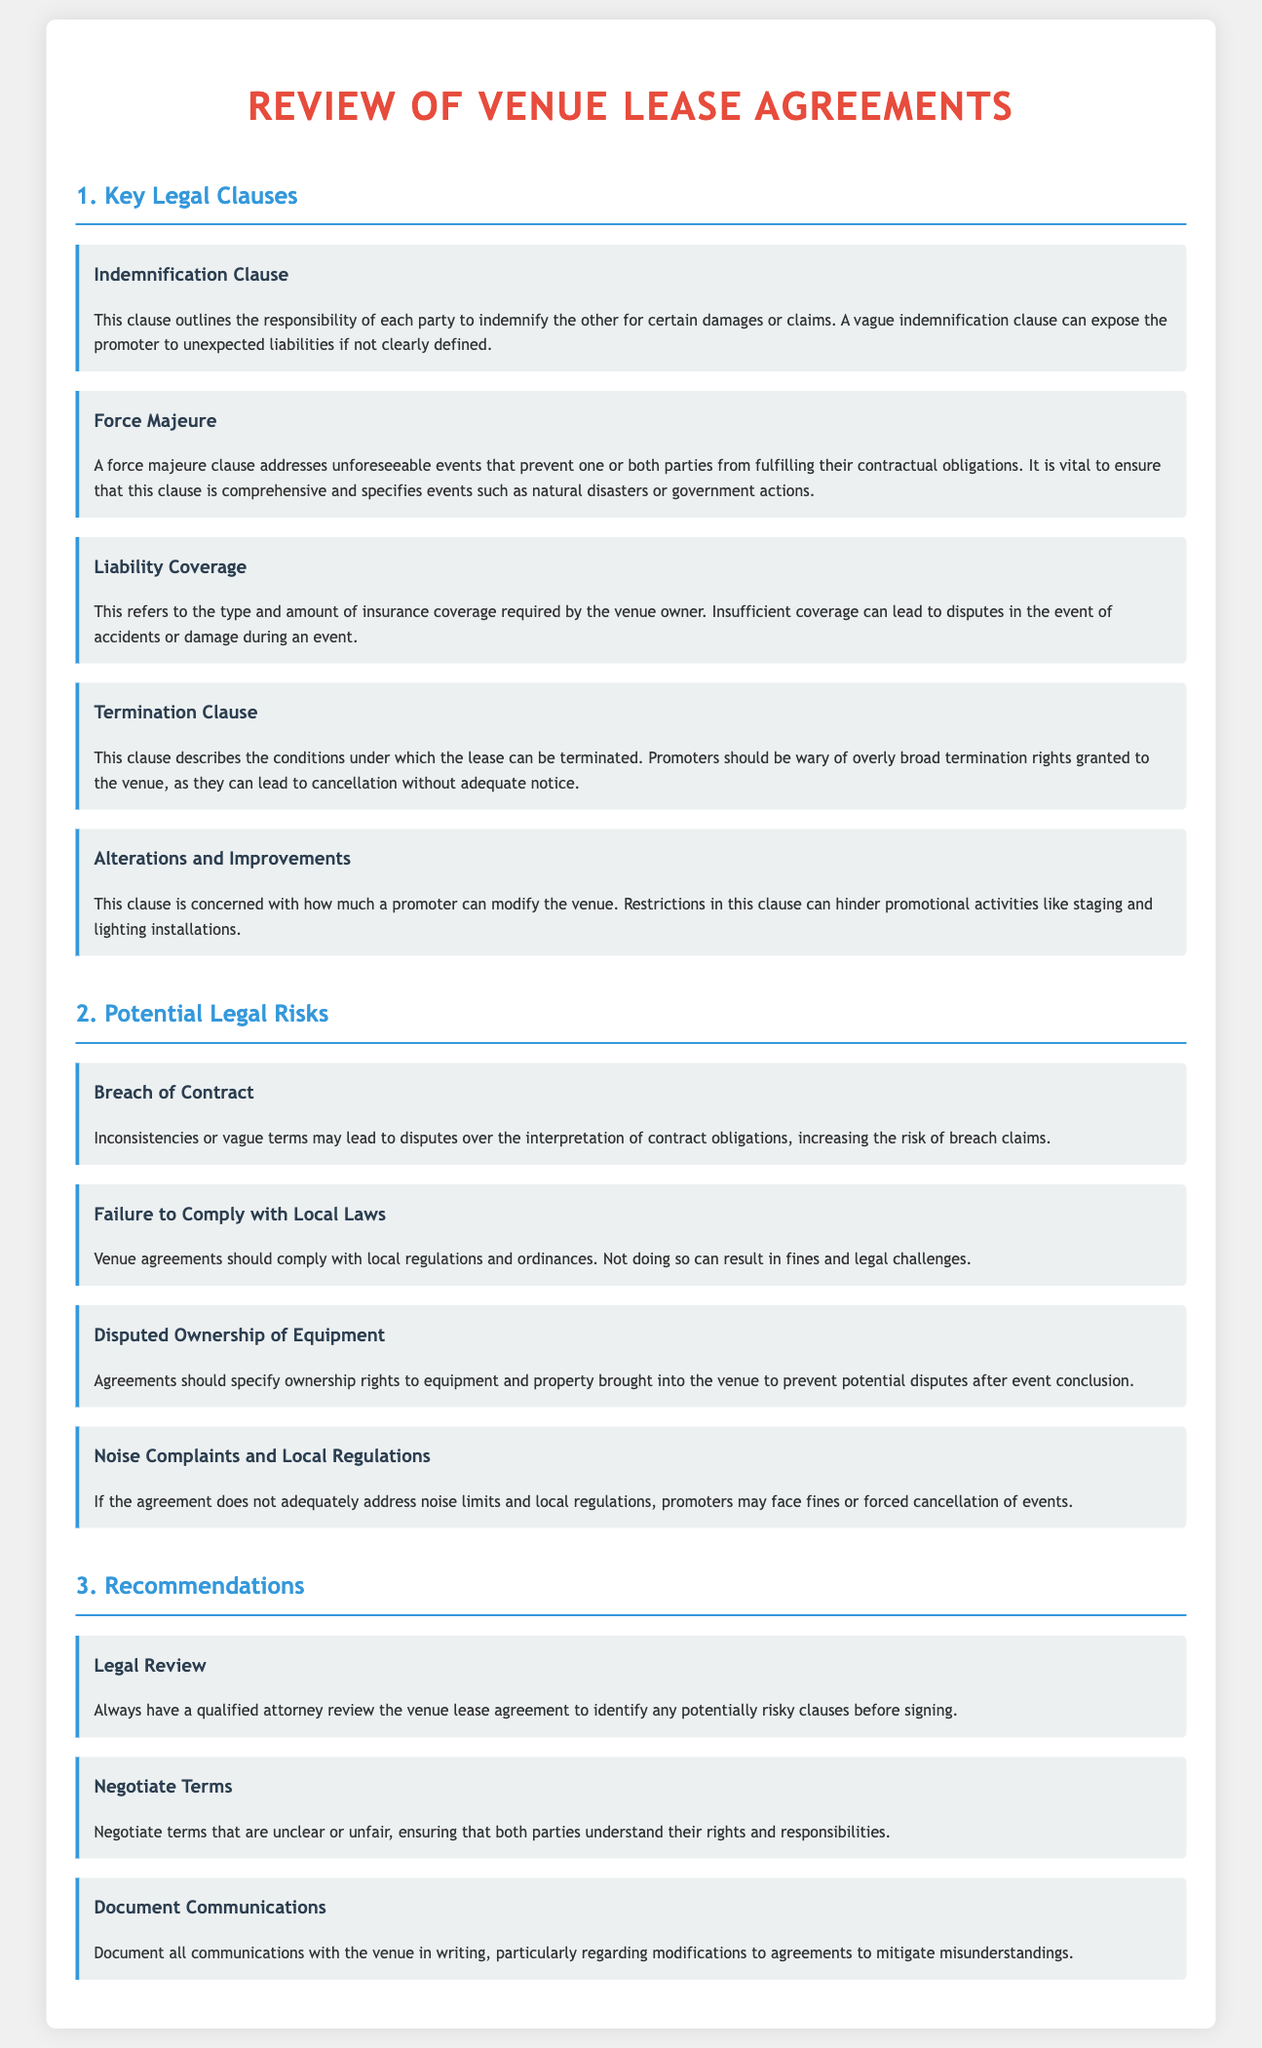What is the title of the document? The title of the document is prominently displayed at the top, indicating the subject matter of the content.
Answer: Review of Venue Lease Agreements What is covered under the Indemnification Clause? The Indemnification Clause outlines the responsibility of each party to indemnify the other for certain damages or claims.
Answer: Responsibility for damages or claims What is a potential risk associated with vague terms in the contract? Vague terms may lead to increased risk of breach claims because of disputes over contract obligations.
Answer: Breach of Contract What should promoters verify in the Liability Coverage clause? Promoters should check the type and amount of insurance coverage required by the venue owner to avoid disputes.
Answer: Type and amount of insurance coverage What is a recommended action before signing the venue lease agreement? The recommendation suggests having a qualified attorney review the agreement for potentially risky clauses.
Answer: Legal Review What does the Force Majeure clause address? This clause addresses unforeseeable events that prevent one or both parties from fulfilling their contractual obligations.
Answer: Unforeseeable events Is it important for venue agreements to comply with local regulations? Yes, compliance with local regulations and ordinances is essential to avoid fines and legal challenges.
Answer: Yes What rights should be specified regarding equipment in the agreement? The agreement should specify ownership rights to prevent disputes after the event conclusion.
Answer: Ownership rights What type of clause can hinder promotional activities? The Alterations and Improvements clause can restrict modifications that promote staging and lighting installations.
Answer: Alterations and Improvements 